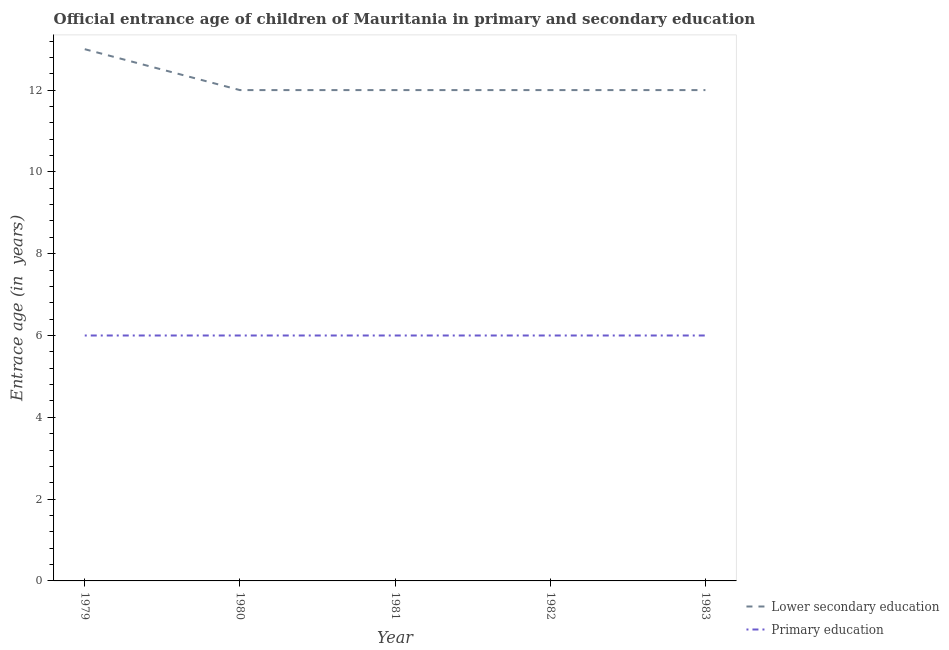Does the line corresponding to entrance age of chiildren in primary education intersect with the line corresponding to entrance age of children in lower secondary education?
Your answer should be very brief. No. What is the entrance age of children in lower secondary education in 1982?
Offer a very short reply. 12. Across all years, what is the maximum entrance age of chiildren in primary education?
Offer a very short reply. 6. In which year was the entrance age of children in lower secondary education maximum?
Offer a very short reply. 1979. In which year was the entrance age of chiildren in primary education minimum?
Ensure brevity in your answer.  1979. What is the total entrance age of chiildren in primary education in the graph?
Give a very brief answer. 30. What is the difference between the entrance age of children in lower secondary education in 1982 and that in 1983?
Offer a terse response. 0. In how many years, is the entrance age of chiildren in primary education greater than 6.4 years?
Ensure brevity in your answer.  0. Is the entrance age of children in lower secondary education in 1979 less than that in 1981?
Offer a terse response. No. Is the difference between the entrance age of chiildren in primary education in 1979 and 1983 greater than the difference between the entrance age of children in lower secondary education in 1979 and 1983?
Make the answer very short. No. What is the difference between the highest and the second highest entrance age of children in lower secondary education?
Offer a very short reply. 1. What is the difference between the highest and the lowest entrance age of children in lower secondary education?
Offer a very short reply. 1. In how many years, is the entrance age of children in lower secondary education greater than the average entrance age of children in lower secondary education taken over all years?
Your answer should be very brief. 1. Are the values on the major ticks of Y-axis written in scientific E-notation?
Make the answer very short. No. Does the graph contain any zero values?
Ensure brevity in your answer.  No. What is the title of the graph?
Provide a succinct answer. Official entrance age of children of Mauritania in primary and secondary education. Does "Exports" appear as one of the legend labels in the graph?
Give a very brief answer. No. What is the label or title of the X-axis?
Provide a succinct answer. Year. What is the label or title of the Y-axis?
Your answer should be very brief. Entrace age (in  years). What is the Entrace age (in  years) of Primary education in 1980?
Provide a short and direct response. 6. What is the Entrace age (in  years) of Primary education in 1981?
Provide a short and direct response. 6. Across all years, what is the minimum Entrace age (in  years) of Lower secondary education?
Keep it short and to the point. 12. Across all years, what is the minimum Entrace age (in  years) of Primary education?
Your answer should be very brief. 6. What is the difference between the Entrace age (in  years) in Primary education in 1979 and that in 1981?
Offer a very short reply. 0. What is the difference between the Entrace age (in  years) of Primary education in 1979 and that in 1982?
Make the answer very short. 0. What is the difference between the Entrace age (in  years) in Lower secondary education in 1979 and that in 1983?
Offer a terse response. 1. What is the difference between the Entrace age (in  years) of Primary education in 1979 and that in 1983?
Keep it short and to the point. 0. What is the difference between the Entrace age (in  years) in Primary education in 1980 and that in 1981?
Your answer should be very brief. 0. What is the difference between the Entrace age (in  years) of Lower secondary education in 1980 and that in 1983?
Your answer should be compact. 0. What is the difference between the Entrace age (in  years) in Lower secondary education in 1981 and that in 1982?
Provide a short and direct response. 0. What is the difference between the Entrace age (in  years) of Primary education in 1981 and that in 1983?
Offer a very short reply. 0. What is the difference between the Entrace age (in  years) of Lower secondary education in 1982 and that in 1983?
Provide a succinct answer. 0. What is the difference between the Entrace age (in  years) in Lower secondary education in 1979 and the Entrace age (in  years) in Primary education in 1981?
Provide a succinct answer. 7. What is the difference between the Entrace age (in  years) of Lower secondary education in 1980 and the Entrace age (in  years) of Primary education in 1983?
Make the answer very short. 6. What is the difference between the Entrace age (in  years) in Lower secondary education in 1982 and the Entrace age (in  years) in Primary education in 1983?
Offer a very short reply. 6. What is the average Entrace age (in  years) in Lower secondary education per year?
Offer a terse response. 12.2. What is the average Entrace age (in  years) in Primary education per year?
Offer a very short reply. 6. In the year 1979, what is the difference between the Entrace age (in  years) in Lower secondary education and Entrace age (in  years) in Primary education?
Your response must be concise. 7. In the year 1983, what is the difference between the Entrace age (in  years) of Lower secondary education and Entrace age (in  years) of Primary education?
Your answer should be compact. 6. What is the ratio of the Entrace age (in  years) in Lower secondary education in 1979 to that in 1980?
Ensure brevity in your answer.  1.08. What is the ratio of the Entrace age (in  years) in Lower secondary education in 1979 to that in 1981?
Your answer should be compact. 1.08. What is the ratio of the Entrace age (in  years) of Primary education in 1979 to that in 1981?
Make the answer very short. 1. What is the ratio of the Entrace age (in  years) of Lower secondary education in 1979 to that in 1982?
Provide a short and direct response. 1.08. What is the ratio of the Entrace age (in  years) of Primary education in 1979 to that in 1983?
Your answer should be compact. 1. What is the ratio of the Entrace age (in  years) of Primary education in 1980 to that in 1981?
Give a very brief answer. 1. What is the ratio of the Entrace age (in  years) in Lower secondary education in 1980 to that in 1982?
Your response must be concise. 1. What is the ratio of the Entrace age (in  years) in Primary education in 1980 to that in 1982?
Offer a terse response. 1. What is the ratio of the Entrace age (in  years) of Lower secondary education in 1980 to that in 1983?
Your answer should be compact. 1. What is the ratio of the Entrace age (in  years) in Lower secondary education in 1981 to that in 1982?
Your answer should be compact. 1. What is the ratio of the Entrace age (in  years) in Primary education in 1981 to that in 1982?
Your answer should be compact. 1. What is the ratio of the Entrace age (in  years) in Lower secondary education in 1981 to that in 1983?
Keep it short and to the point. 1. What is the ratio of the Entrace age (in  years) of Lower secondary education in 1982 to that in 1983?
Ensure brevity in your answer.  1. What is the difference between the highest and the second highest Entrace age (in  years) in Lower secondary education?
Offer a very short reply. 1. What is the difference between the highest and the second highest Entrace age (in  years) of Primary education?
Provide a succinct answer. 0. What is the difference between the highest and the lowest Entrace age (in  years) in Primary education?
Provide a succinct answer. 0. 